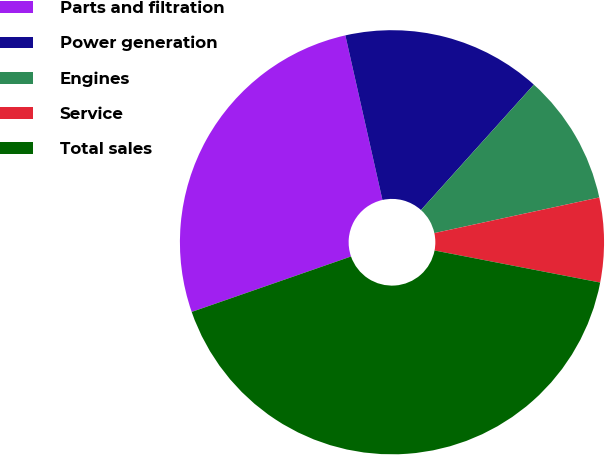<chart> <loc_0><loc_0><loc_500><loc_500><pie_chart><fcel>Parts and filtration<fcel>Power generation<fcel>Engines<fcel>Service<fcel>Total sales<nl><fcel>26.8%<fcel>15.19%<fcel>9.95%<fcel>6.43%<fcel>41.63%<nl></chart> 